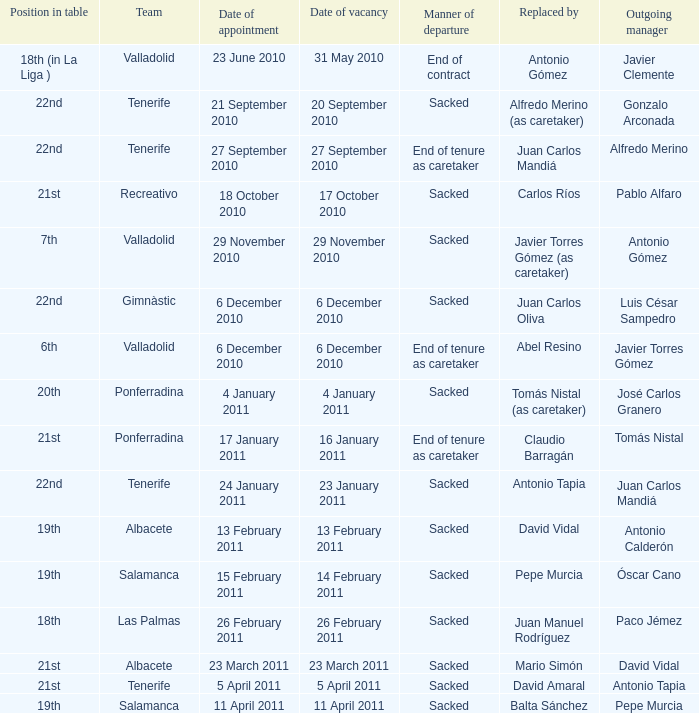What was the appointment date for outgoing manager luis césar sampedro 6 December 2010. 